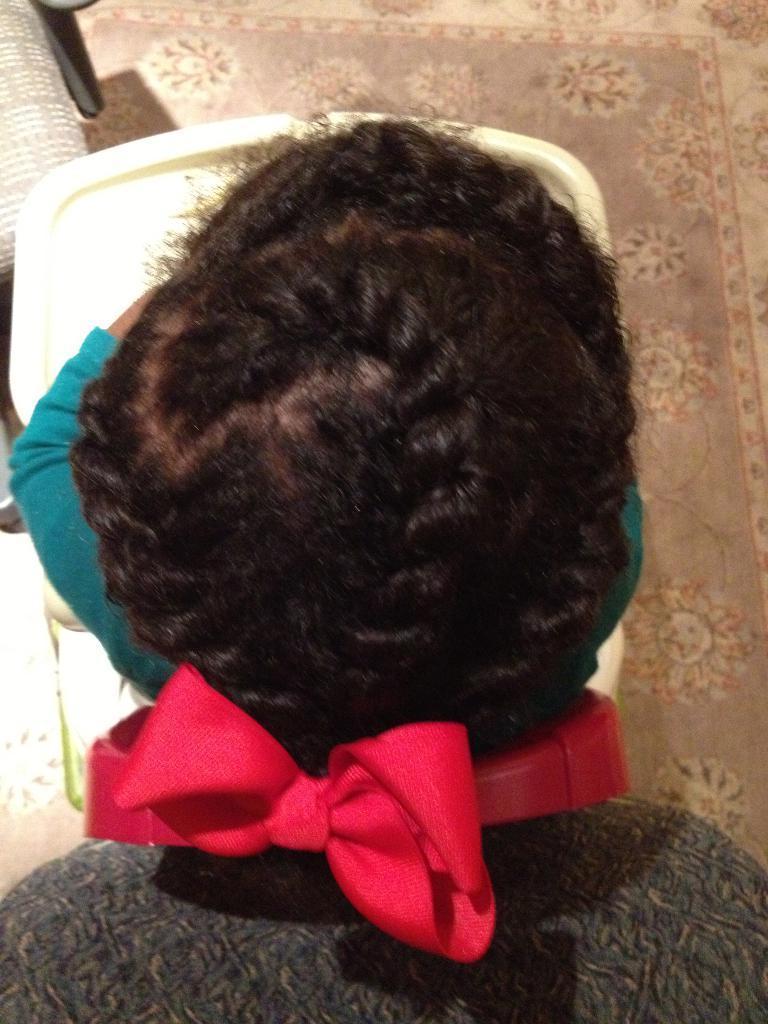In one or two sentences, can you explain what this image depicts? In this image there is a person sitting on the chair. In front of her there is a table and a chair. Behind her there is a chair. At the bottom of the image there is a mat. 